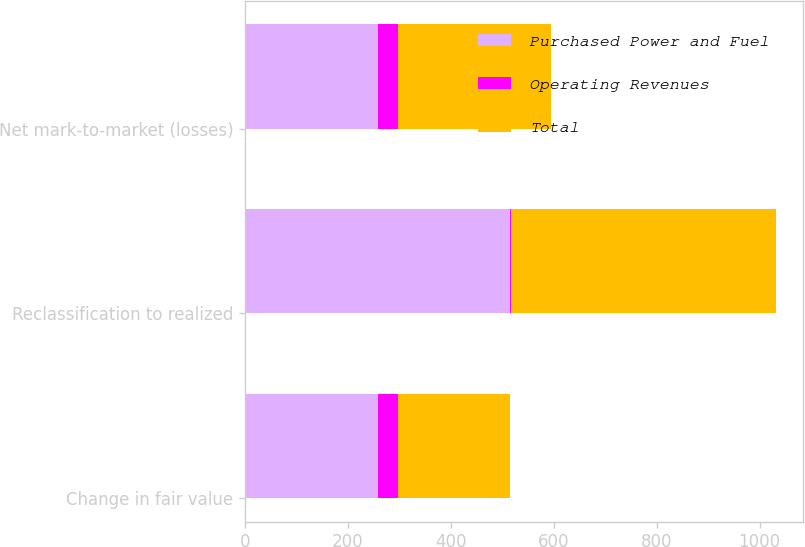Convert chart to OTSL. <chart><loc_0><loc_0><loc_500><loc_500><stacked_bar_chart><ecel><fcel>Change in fair value<fcel>Reclassification to realized<fcel>Net mark-to-market (losses)<nl><fcel>Purchased Power and Fuel<fcel>258<fcel>516<fcel>258<nl><fcel>Operating Revenues<fcel>40<fcel>1<fcel>39<nl><fcel>Total<fcel>218<fcel>515<fcel>297<nl></chart> 